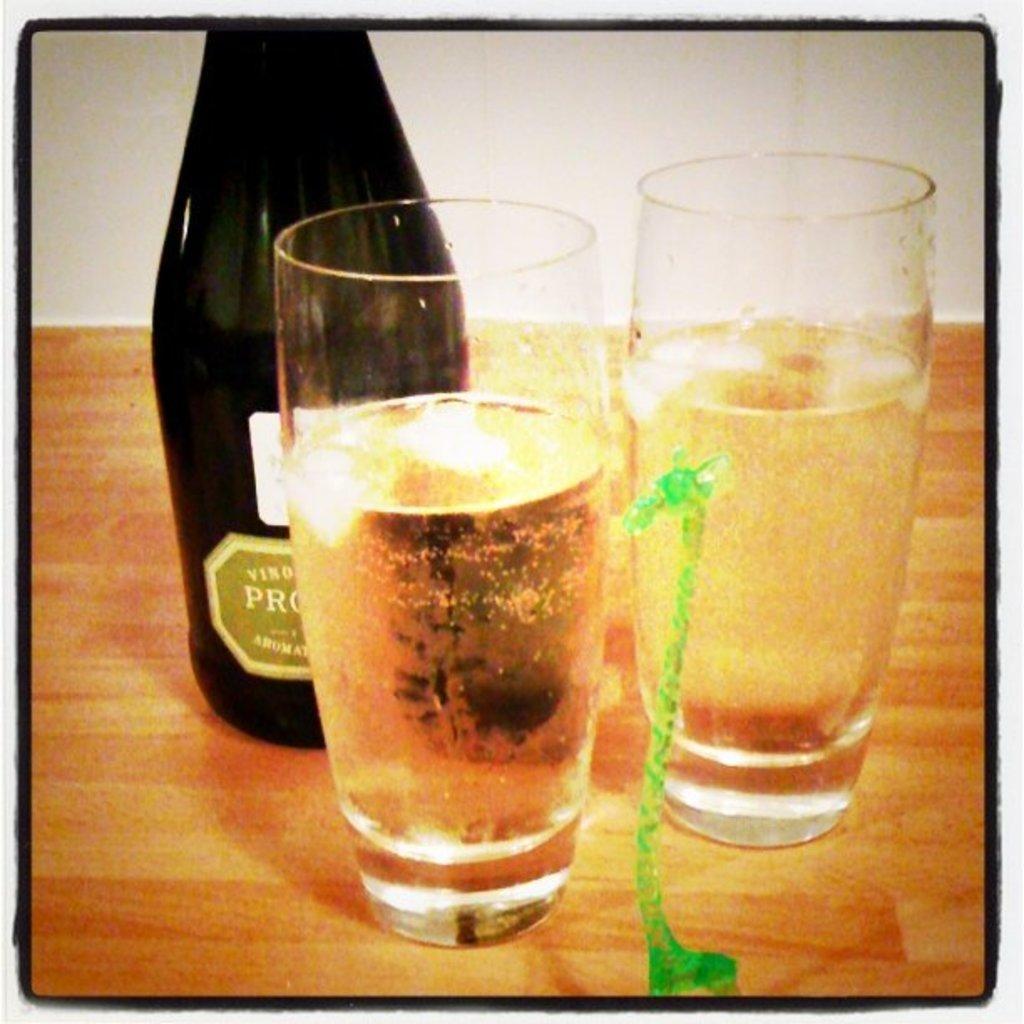How would you summarize this image in a sentence or two? In this image I can see a bottle, few glasses, a green colour thing and in these glasses I can see drinks. On this bottle I can see something is written. 